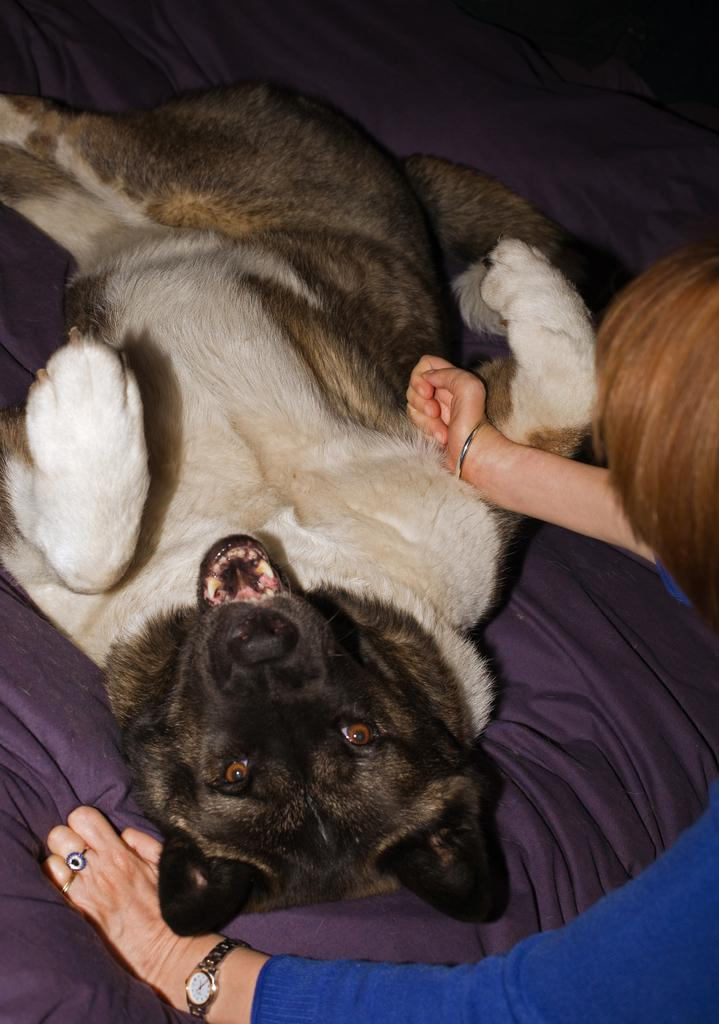Who or what is the main subject in the image? There is a person in the image. What is the person wearing? The person is wearing a blue dress. What other living creature is present in the image? There is a dog in the image. What is the dog doing in the image? The dog is laying on a bed. How close are the person and the dog in the image? The person and the dog are in close proximity. What type of respect can be seen between the person and the salt in the image? There is no salt present in the image, and therefore no interaction or respect between the person and salt can be observed. 